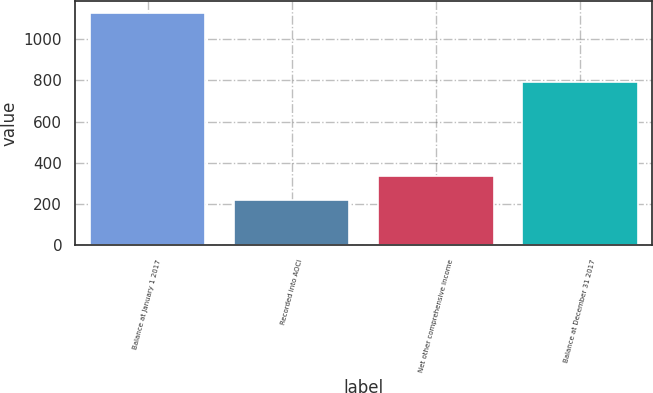<chart> <loc_0><loc_0><loc_500><loc_500><bar_chart><fcel>Balance at January 1 2017<fcel>Recorded into AOCI<fcel>Net other comprehensive income<fcel>Balance at December 31 2017<nl><fcel>1128.1<fcel>219.7<fcel>334.5<fcel>793.6<nl></chart> 